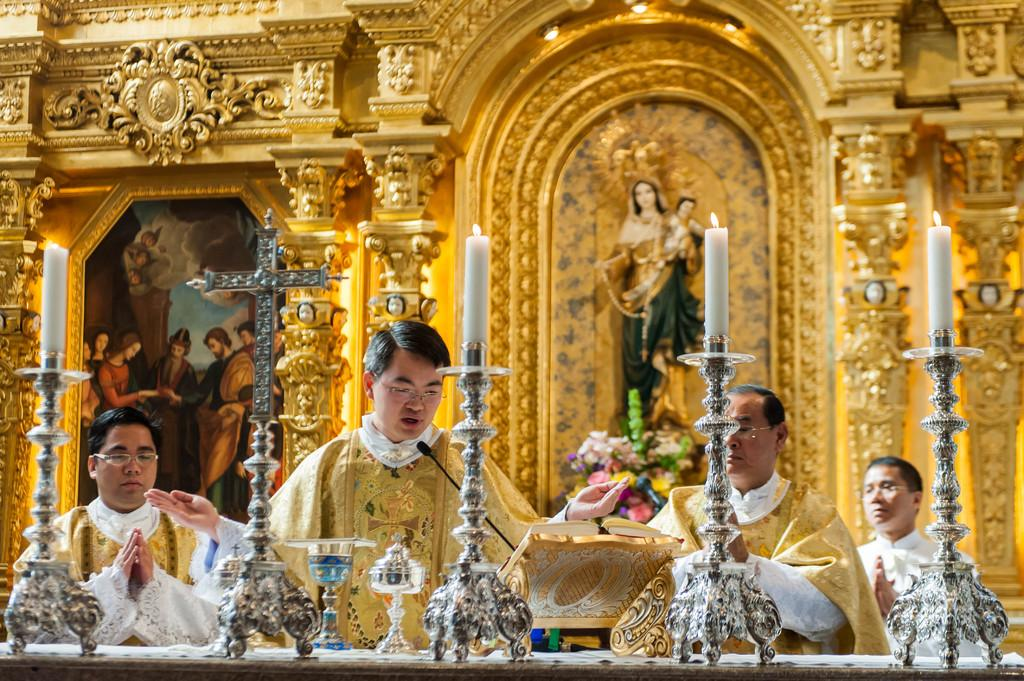How many people are present in the image? There are four persons in the image. What objects can be seen in the image related to light? There are candles in the image. What type of decorative item is present in the image? There is a flower bouquet in the image. What artistic object can be seen in the image? There is a sculpture in the image. What is visible in the background of the image? There is a frame and a design wall in the background of the image. What type of thought can be seen floating in the air in the image? There is no thought visible in the image; it is not a representation of thoughts or ideas. 